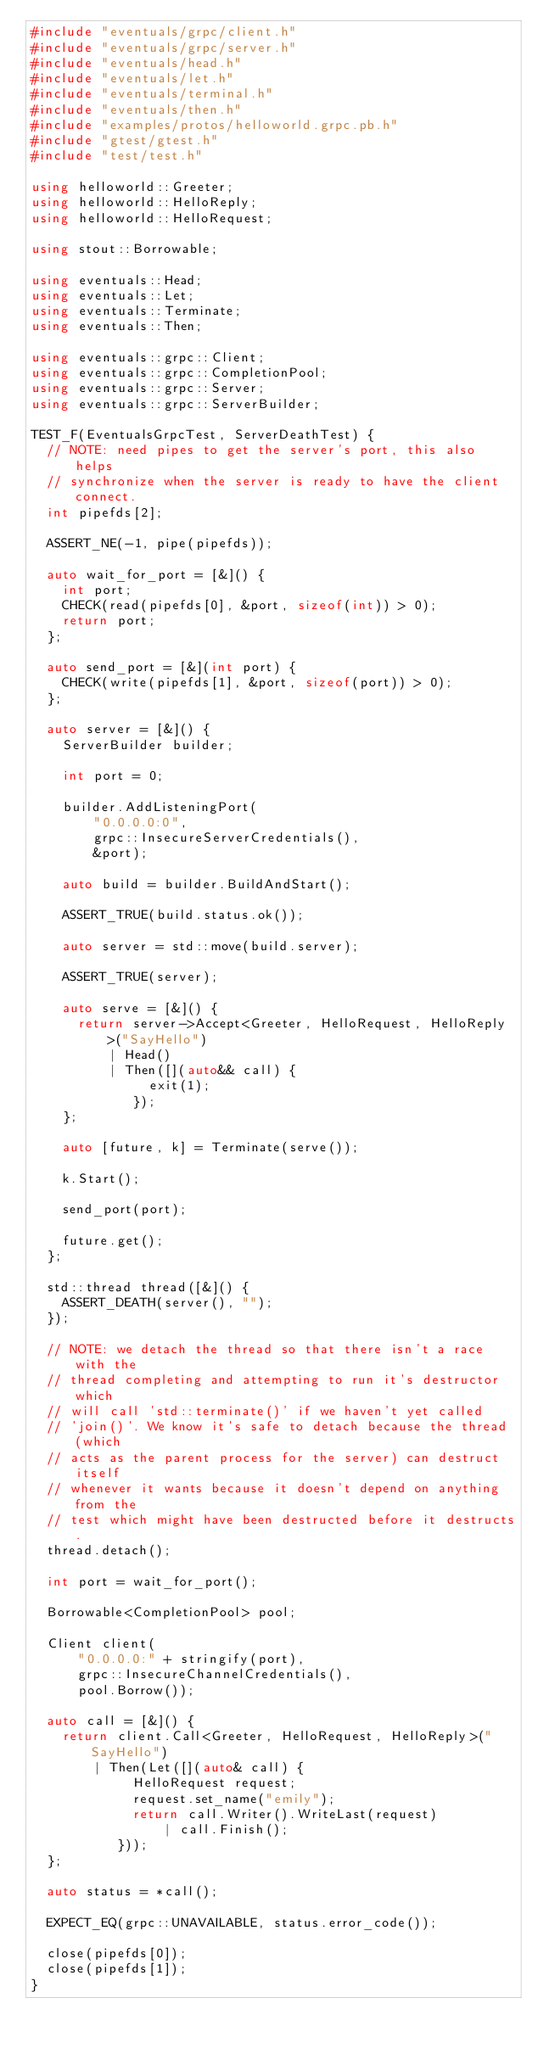Convert code to text. <code><loc_0><loc_0><loc_500><loc_500><_C++_>#include "eventuals/grpc/client.h"
#include "eventuals/grpc/server.h"
#include "eventuals/head.h"
#include "eventuals/let.h"
#include "eventuals/terminal.h"
#include "eventuals/then.h"
#include "examples/protos/helloworld.grpc.pb.h"
#include "gtest/gtest.h"
#include "test/test.h"

using helloworld::Greeter;
using helloworld::HelloReply;
using helloworld::HelloRequest;

using stout::Borrowable;

using eventuals::Head;
using eventuals::Let;
using eventuals::Terminate;
using eventuals::Then;

using eventuals::grpc::Client;
using eventuals::grpc::CompletionPool;
using eventuals::grpc::Server;
using eventuals::grpc::ServerBuilder;

TEST_F(EventualsGrpcTest, ServerDeathTest) {
  // NOTE: need pipes to get the server's port, this also helps
  // synchronize when the server is ready to have the client connect.
  int pipefds[2];

  ASSERT_NE(-1, pipe(pipefds));

  auto wait_for_port = [&]() {
    int port;
    CHECK(read(pipefds[0], &port, sizeof(int)) > 0);
    return port;
  };

  auto send_port = [&](int port) {
    CHECK(write(pipefds[1], &port, sizeof(port)) > 0);
  };

  auto server = [&]() {
    ServerBuilder builder;

    int port = 0;

    builder.AddListeningPort(
        "0.0.0.0:0",
        grpc::InsecureServerCredentials(),
        &port);

    auto build = builder.BuildAndStart();

    ASSERT_TRUE(build.status.ok());

    auto server = std::move(build.server);

    ASSERT_TRUE(server);

    auto serve = [&]() {
      return server->Accept<Greeter, HelloRequest, HelloReply>("SayHello")
          | Head()
          | Then([](auto&& call) {
               exit(1);
             });
    };

    auto [future, k] = Terminate(serve());

    k.Start();

    send_port(port);

    future.get();
  };

  std::thread thread([&]() {
    ASSERT_DEATH(server(), "");
  });

  // NOTE: we detach the thread so that there isn't a race with the
  // thread completing and attempting to run it's destructor which
  // will call 'std::terminate()' if we haven't yet called
  // 'join()'. We know it's safe to detach because the thread (which
  // acts as the parent process for the server) can destruct itself
  // whenever it wants because it doesn't depend on anything from the
  // test which might have been destructed before it destructs.
  thread.detach();

  int port = wait_for_port();

  Borrowable<CompletionPool> pool;

  Client client(
      "0.0.0.0:" + stringify(port),
      grpc::InsecureChannelCredentials(),
      pool.Borrow());

  auto call = [&]() {
    return client.Call<Greeter, HelloRequest, HelloReply>("SayHello")
        | Then(Let([](auto& call) {
             HelloRequest request;
             request.set_name("emily");
             return call.Writer().WriteLast(request)
                 | call.Finish();
           }));
  };

  auto status = *call();

  EXPECT_EQ(grpc::UNAVAILABLE, status.error_code());

  close(pipefds[0]);
  close(pipefds[1]);
}
</code> 